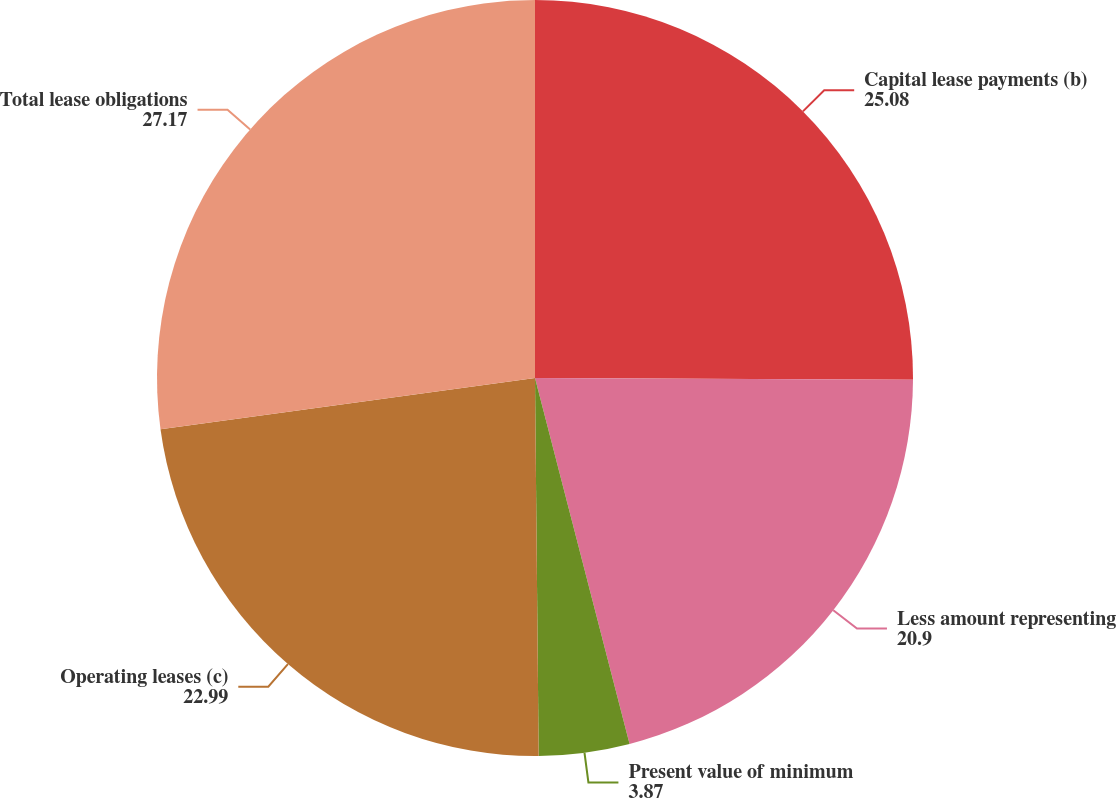<chart> <loc_0><loc_0><loc_500><loc_500><pie_chart><fcel>Capital lease payments (b)<fcel>Less amount representing<fcel>Present value of minimum<fcel>Operating leases (c)<fcel>Total lease obligations<nl><fcel>25.08%<fcel>20.9%<fcel>3.87%<fcel>22.99%<fcel>27.17%<nl></chart> 